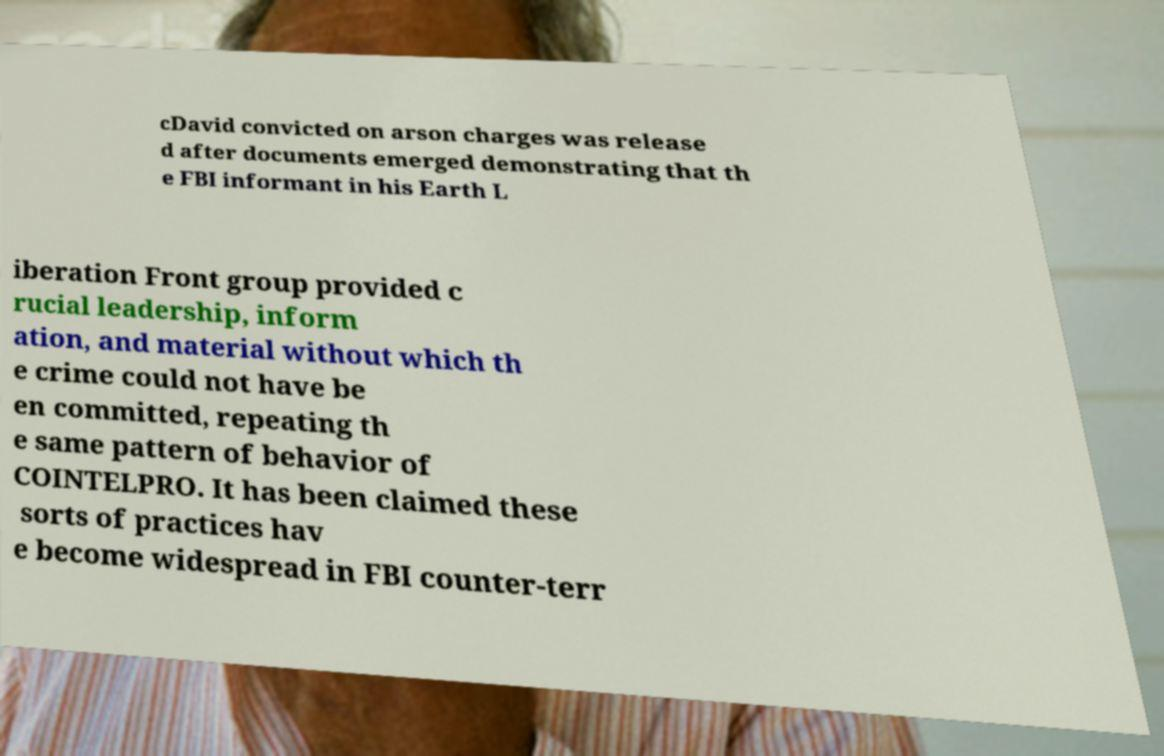Please identify and transcribe the text found in this image. cDavid convicted on arson charges was release d after documents emerged demonstrating that th e FBI informant in his Earth L iberation Front group provided c rucial leadership, inform ation, and material without which th e crime could not have be en committed, repeating th e same pattern of behavior of COINTELPRO. It has been claimed these sorts of practices hav e become widespread in FBI counter-terr 